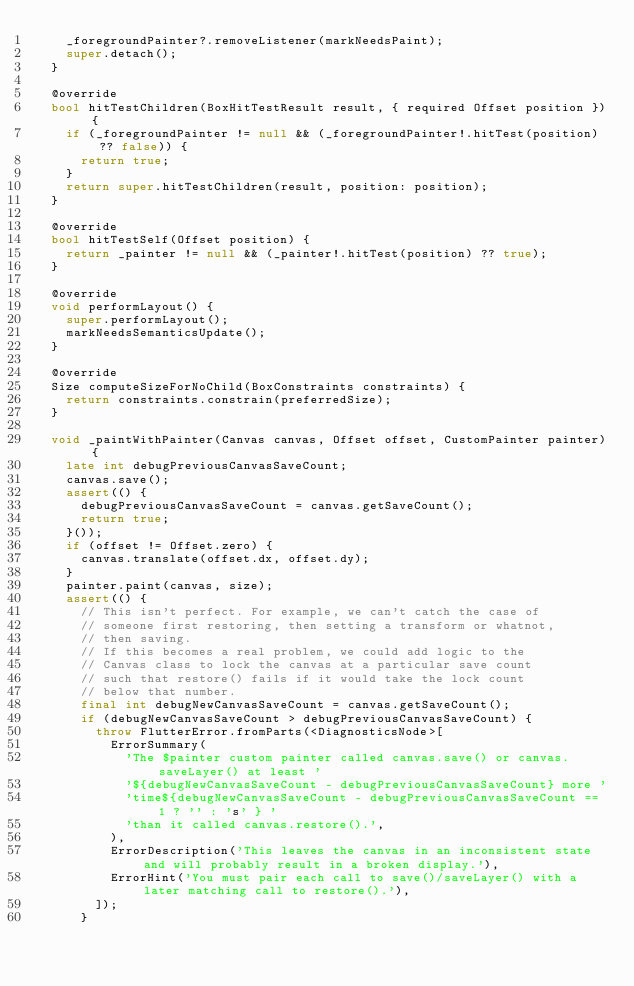Convert code to text. <code><loc_0><loc_0><loc_500><loc_500><_Dart_>    _foregroundPainter?.removeListener(markNeedsPaint);
    super.detach();
  }

  @override
  bool hitTestChildren(BoxHitTestResult result, { required Offset position }) {
    if (_foregroundPainter != null && (_foregroundPainter!.hitTest(position) ?? false)) {
      return true;
    }
    return super.hitTestChildren(result, position: position);
  }

  @override
  bool hitTestSelf(Offset position) {
    return _painter != null && (_painter!.hitTest(position) ?? true);
  }

  @override
  void performLayout() {
    super.performLayout();
    markNeedsSemanticsUpdate();
  }

  @override
  Size computeSizeForNoChild(BoxConstraints constraints) {
    return constraints.constrain(preferredSize);
  }

  void _paintWithPainter(Canvas canvas, Offset offset, CustomPainter painter) {
    late int debugPreviousCanvasSaveCount;
    canvas.save();
    assert(() {
      debugPreviousCanvasSaveCount = canvas.getSaveCount();
      return true;
    }());
    if (offset != Offset.zero) {
      canvas.translate(offset.dx, offset.dy);
    }
    painter.paint(canvas, size);
    assert(() {
      // This isn't perfect. For example, we can't catch the case of
      // someone first restoring, then setting a transform or whatnot,
      // then saving.
      // If this becomes a real problem, we could add logic to the
      // Canvas class to lock the canvas at a particular save count
      // such that restore() fails if it would take the lock count
      // below that number.
      final int debugNewCanvasSaveCount = canvas.getSaveCount();
      if (debugNewCanvasSaveCount > debugPreviousCanvasSaveCount) {
        throw FlutterError.fromParts(<DiagnosticsNode>[
          ErrorSummary(
            'The $painter custom painter called canvas.save() or canvas.saveLayer() at least '
            '${debugNewCanvasSaveCount - debugPreviousCanvasSaveCount} more '
            'time${debugNewCanvasSaveCount - debugPreviousCanvasSaveCount == 1 ? '' : 's' } '
            'than it called canvas.restore().',
          ),
          ErrorDescription('This leaves the canvas in an inconsistent state and will probably result in a broken display.'),
          ErrorHint('You must pair each call to save()/saveLayer() with a later matching call to restore().'),
        ]);
      }</code> 